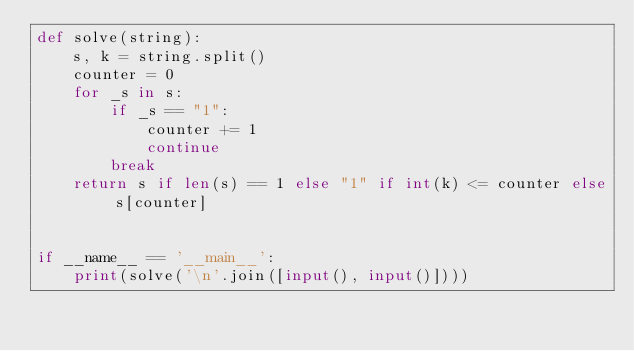<code> <loc_0><loc_0><loc_500><loc_500><_Python_>def solve(string):
    s, k = string.split()
    counter = 0
    for _s in s:
        if _s == "1":
            counter += 1
            continue
        break
    return s if len(s) == 1 else "1" if int(k) <= counter else s[counter]


if __name__ == '__main__':
    print(solve('\n'.join([input(), input()])))
</code> 